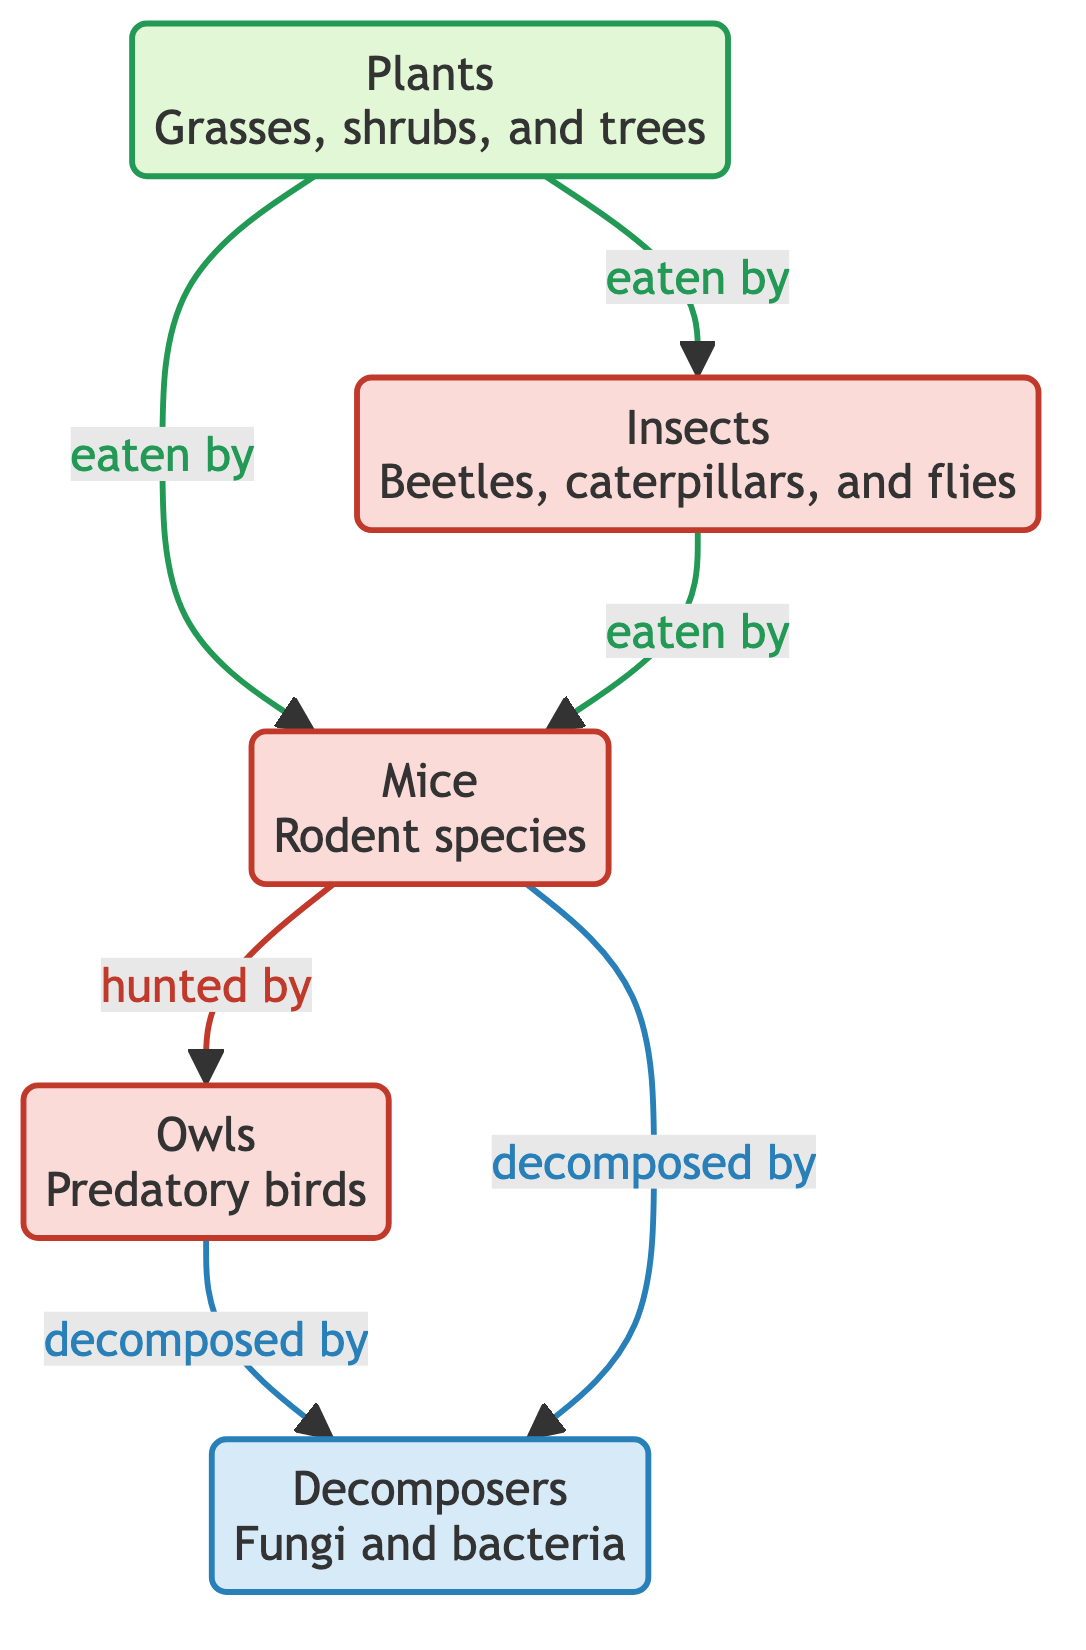What are the producers in this ecosystem? The diagram identifies "Plants" as the producer category, which includes grasses, shrubs, and trees. This is visually represented by the node labeled "Plants."
Answer: Plants How many consumers are depicted in this food chain? The diagram shows three consumer nodes: "Insects," "Mice," and "Owls." Counting these nodes gives us three consumers in total.
Answer: 3 Which organism is at the top of the food chain? The diagram shows "Owls" as the apex predator, meaning they are at the top, as they hunt mice and are not hunted by any other depicted organism.
Answer: Owls What do mice primarily eat? The diagram indicates that "Mice" consume both "Plants" and "Insects." Observing the arrows from both nodes pointing to "Mice" shows their food sources.
Answer: Plants and Insects Which organisms are decomposed in this ecosystem? The diagram indicates that both "Owls" and "Mice" are decomposed by "Decomposers," as evidenced by the arrows pointing from these two nodes to the decomposer node.
Answer: Owls and Mice How many links or edges are there between the nodes? By analyzing the connections between the nodes, the diagram consists of five links: Plants to Insects, Plants to Mice, Insects to Mice, Mice to Owls, and Owls and Mice to Decomposers. Counting these gives a total of five links.
Answer: 5 What role do decomposers play in this food chain? The role of "Decomposers" in the ecosystem, as depicted in the diagram, is to break down organic matter from both "Owls" and "Mice," recycling nutrients back into the ecosystem.
Answer: Break down organic matter Which organisms do insects eat? The diagram shows that "Insects" are primarily consumed by "Mice." The arrow from "Insects" to "Mice" indicates this predatory relationship.
Answer: Mice What type of ecosystem is represented in this food chain? The diagram suggests a suburban ecosystem, as inferred from the context of common organisms like owls and mice typically found in suburban environments.
Answer: Suburban ecosystem 